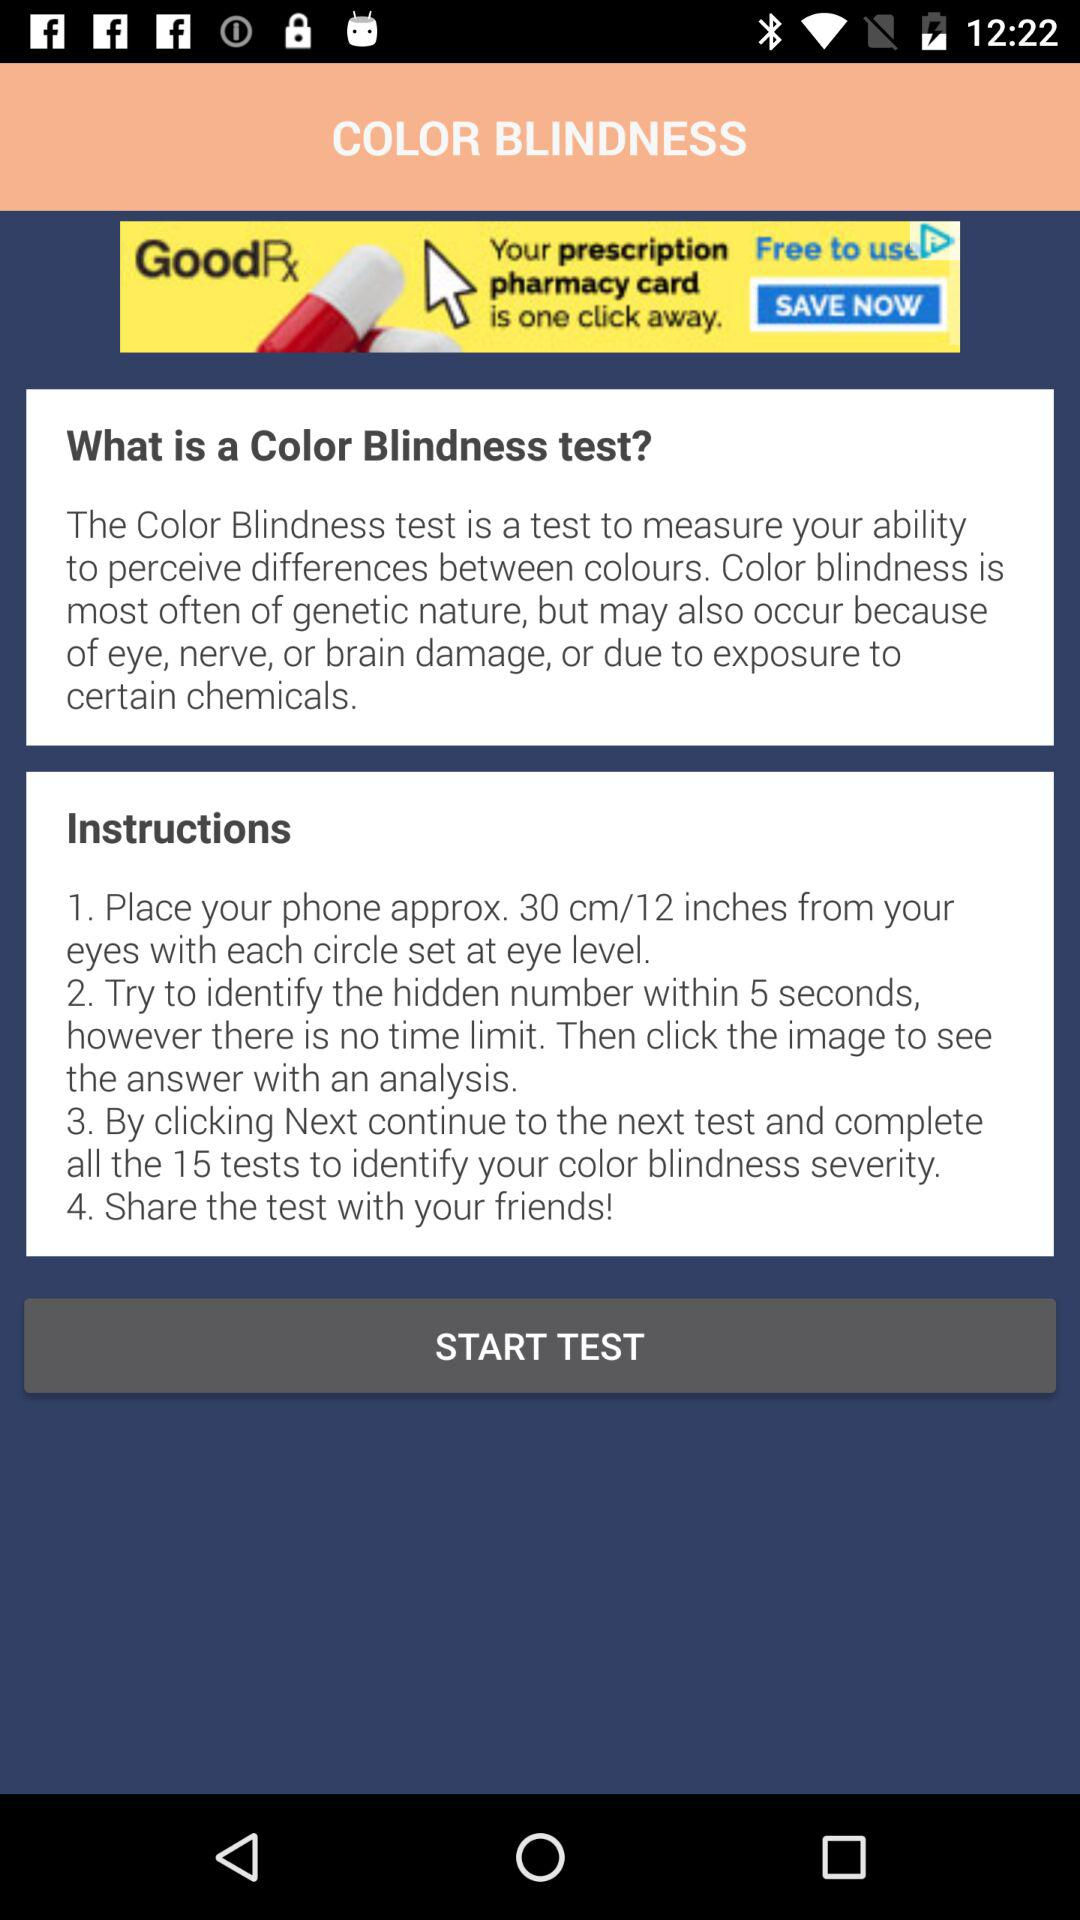How many tests in total are needed to be completed to check for color blindness? There are 15 tests that need to be completed to check for color blindness. 